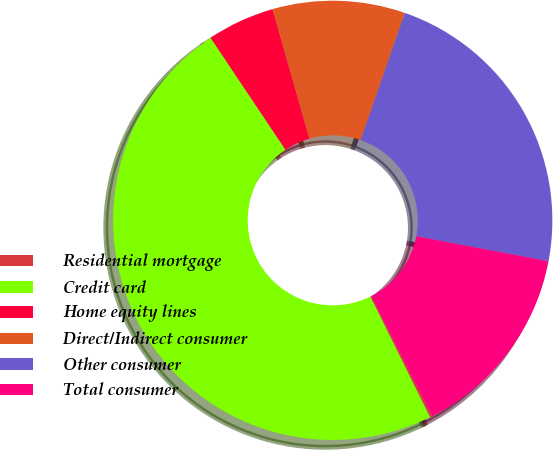<chart> <loc_0><loc_0><loc_500><loc_500><pie_chart><fcel>Residential mortgage<fcel>Credit card<fcel>Home equity lines<fcel>Direct/Indirect consumer<fcel>Other consumer<fcel>Total consumer<nl><fcel>0.18%<fcel>47.92%<fcel>4.96%<fcel>9.75%<fcel>22.65%<fcel>14.53%<nl></chart> 